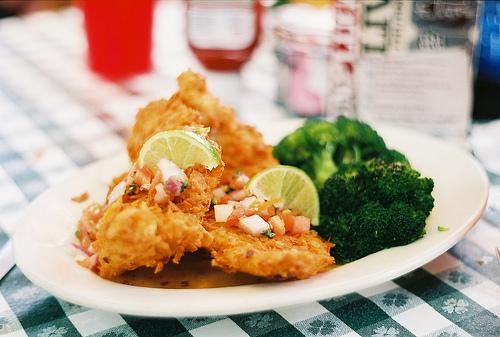Describe the image as if you were writing alt-text for visually impaired users. A white plate filled with battered fish, lime wedges, chopped broccoli, and pico de gallo, set upon a green and white checkered tablecloth outdoors. Write a poetic description of the scene in the image. A burst of flavors in just the right space. Express your admiration for the delicious-looking meal in the image. Wow, what a tempting spread! The golden-brown battered fish, vibrant green broccoli, zingy lime wedges, and colorful pico de gallo truly make for a feast for the senses! Describe the image from the perspective of a chef presenting the dish to a guest. Ladies and gentlemen, I present to you our delectable seafood extravaganza, featuring a perfectly battered fish, complemented with aromatic broccoli, zesty lime wedges, and our house-made pico de gallo. Provide a concise description of the primary scene in the image. A plate of food consisting fish, broccoli, lime wedges, and pico de gallo is placed on a green and white checkered tablecloth. Mention the key elements present in the image using a descriptive style. A delectable meal displays battered fish, tangy lime slices, succulent broccoli, and appetizing pico de gallo arranged elegantly on a round white plate. Write a headline summarizing the main focus of the image. Delicious Outdoor Fish Meal with Flavorful Accompaniments Provide a detailed description of the main subject in the image. A round white plate holds a serving of battered fish, surrounded by crunchy broccoli florets, juicy lime wedges, and a colourful mix of pico de gallo, creating a vibrant and tasty meal. Describe the image considering its setting and atmosphere. An inviting outdoor table adorned with a green and white checkered tablecloth perfectly highlights a scrumptious plate of fish, broccoli, lime wedges, and pico de gallo, making for a delightful dining experience. Imagine you have to describe the image in one sentence for a busy reader. A mouthwatering plate of battered fish, accompanied by broccoli, lime wedges, and pico de gallo, awaits on a green and white checkered tablecloth. 